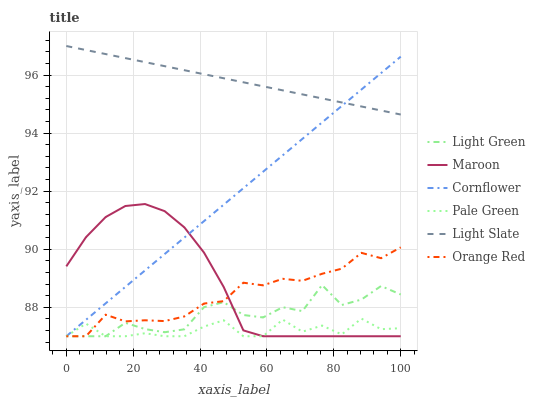Does Pale Green have the minimum area under the curve?
Answer yes or no. Yes. Does Light Slate have the maximum area under the curve?
Answer yes or no. Yes. Does Maroon have the minimum area under the curve?
Answer yes or no. No. Does Maroon have the maximum area under the curve?
Answer yes or no. No. Is Cornflower the smoothest?
Answer yes or no. Yes. Is Light Green the roughest?
Answer yes or no. Yes. Is Light Slate the smoothest?
Answer yes or no. No. Is Light Slate the roughest?
Answer yes or no. No. Does Light Slate have the lowest value?
Answer yes or no. No. Does Light Slate have the highest value?
Answer yes or no. Yes. Does Maroon have the highest value?
Answer yes or no. No. Is Pale Green less than Light Slate?
Answer yes or no. Yes. Is Light Slate greater than Orange Red?
Answer yes or no. Yes. Does Cornflower intersect Light Green?
Answer yes or no. Yes. Is Cornflower less than Light Green?
Answer yes or no. No. Is Cornflower greater than Light Green?
Answer yes or no. No. Does Pale Green intersect Light Slate?
Answer yes or no. No. 